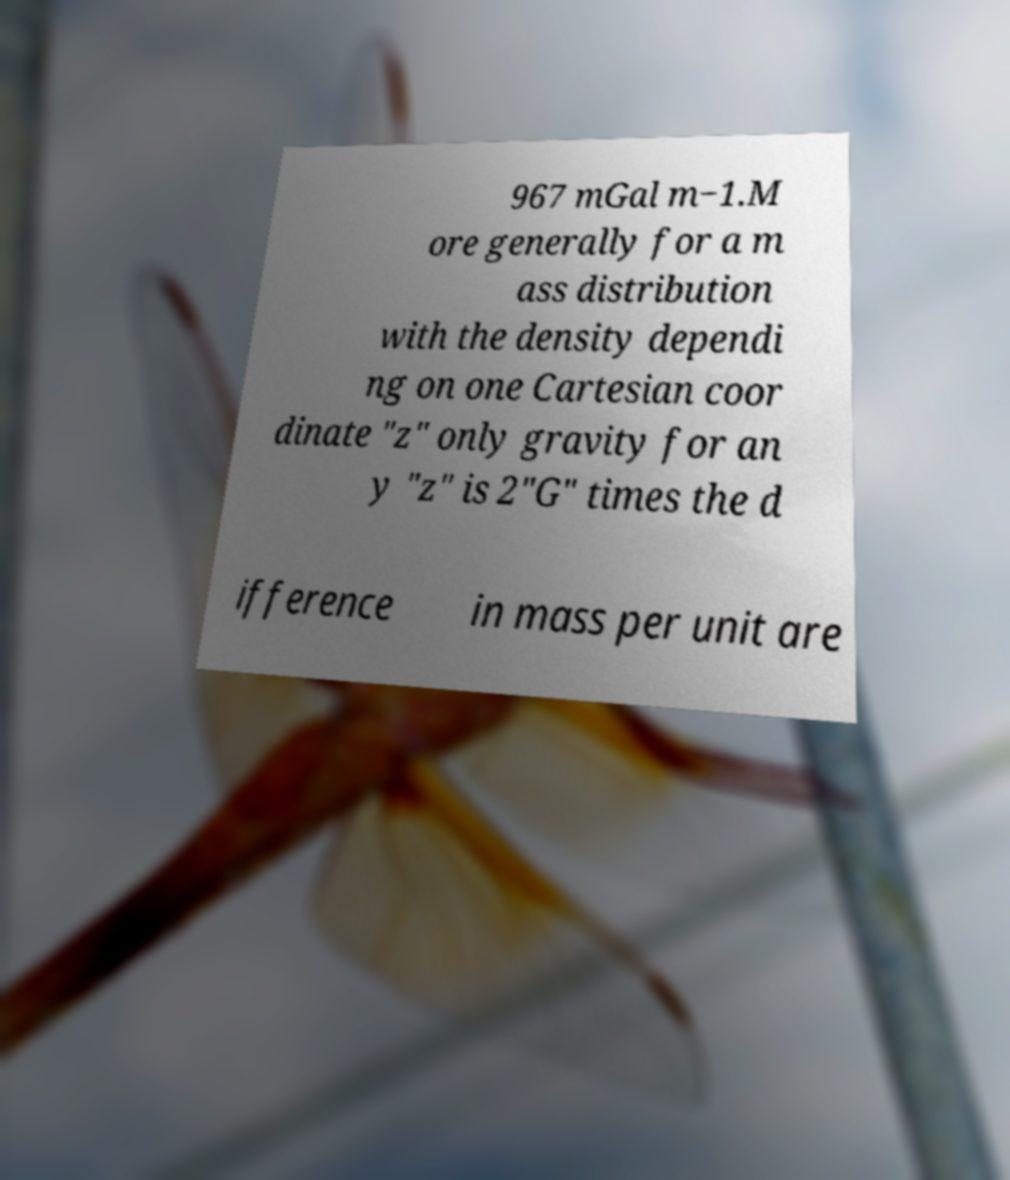Could you assist in decoding the text presented in this image and type it out clearly? 967 mGal m−1.M ore generally for a m ass distribution with the density dependi ng on one Cartesian coor dinate "z" only gravity for an y "z" is 2"G" times the d ifference in mass per unit are 